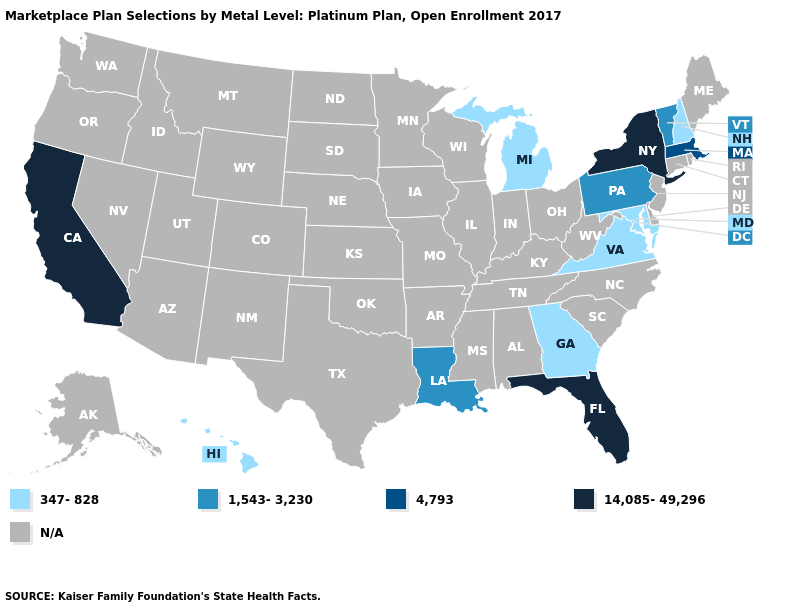What is the value of Kentucky?
Concise answer only. N/A. How many symbols are there in the legend?
Concise answer only. 5. Does Florida have the highest value in the USA?
Give a very brief answer. Yes. What is the value of Kansas?
Be succinct. N/A. Name the states that have a value in the range 1,543-3,230?
Short answer required. Louisiana, Pennsylvania, Vermont. What is the value of Massachusetts?
Concise answer only. 4,793. What is the value of Hawaii?
Short answer required. 347-828. Name the states that have a value in the range 347-828?
Answer briefly. Georgia, Hawaii, Maryland, Michigan, New Hampshire, Virginia. What is the value of Ohio?
Be succinct. N/A. What is the highest value in the USA?
Be succinct. 14,085-49,296. Which states have the lowest value in the Northeast?
Write a very short answer. New Hampshire. What is the lowest value in states that border Maryland?
Answer briefly. 347-828. 